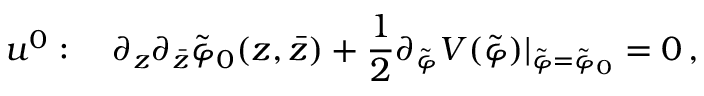Convert formula to latex. <formula><loc_0><loc_0><loc_500><loc_500>u ^ { 0 } \colon \quad \partial _ { z } \partial _ { \bar { z } } \tilde { \varphi } _ { 0 } ( z , \bar { z } ) + \frac { 1 } { 2 } \partial _ { \tilde { \varphi } } V ( \tilde { \varphi } ) | _ { \tilde { \varphi } = \tilde { \varphi } _ { 0 } } = 0 \, ,</formula> 